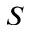<formula> <loc_0><loc_0><loc_500><loc_500>S</formula> 